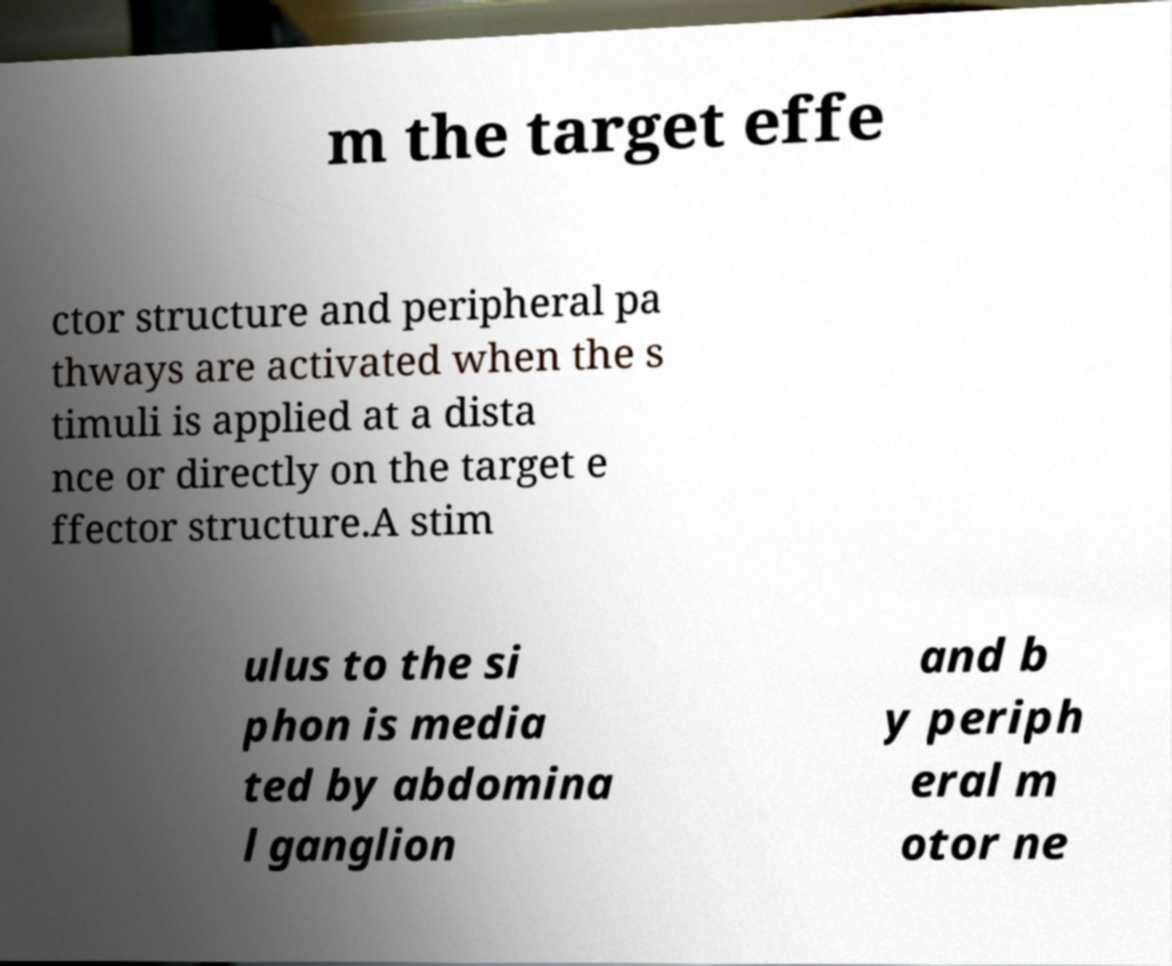Please read and relay the text visible in this image. What does it say? m the target effe ctor structure and peripheral pa thways are activated when the s timuli is applied at a dista nce or directly on the target e ffector structure.A stim ulus to the si phon is media ted by abdomina l ganglion and b y periph eral m otor ne 